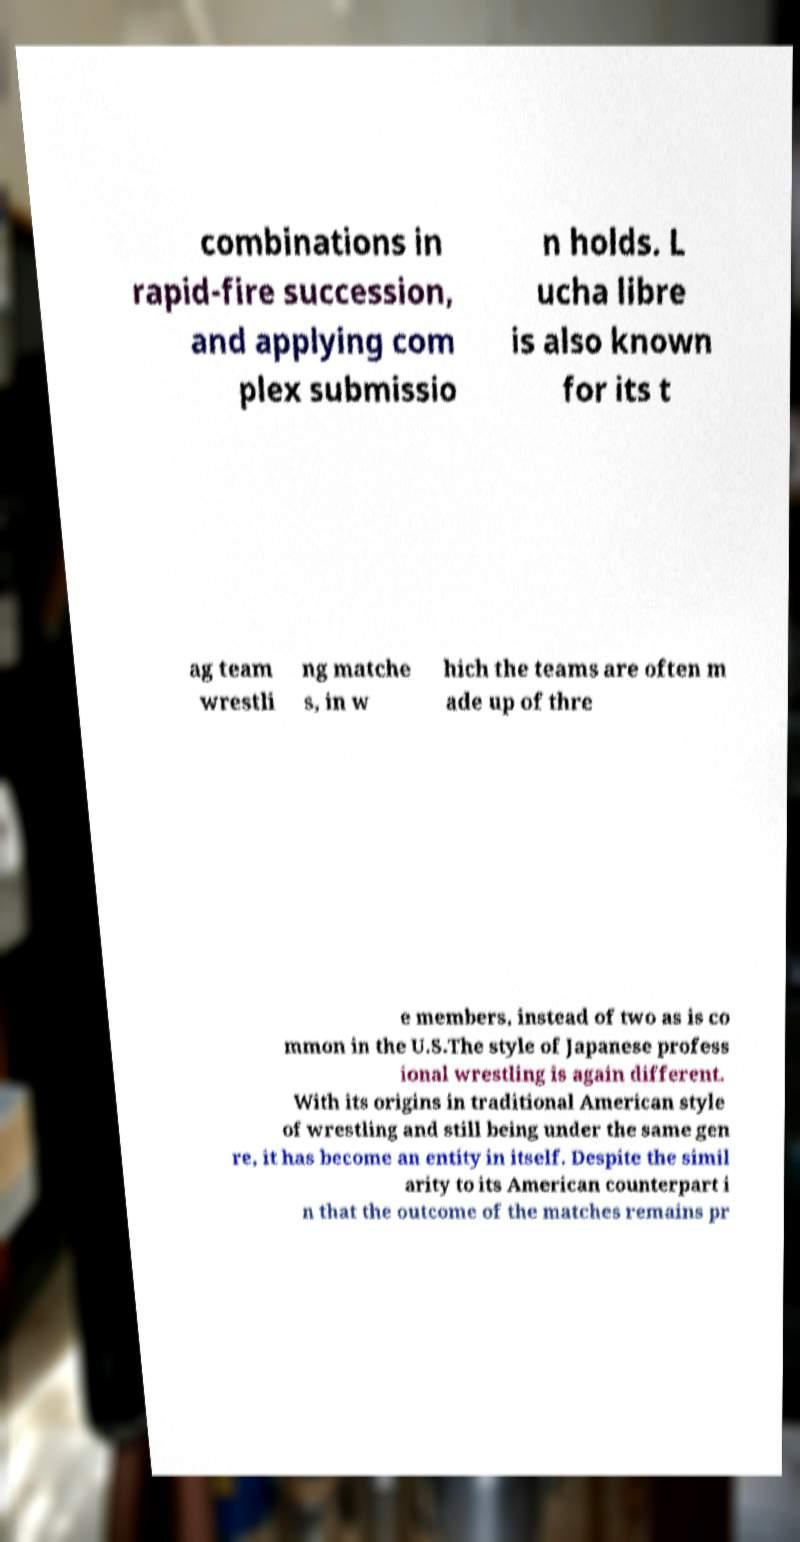There's text embedded in this image that I need extracted. Can you transcribe it verbatim? combinations in rapid-fire succession, and applying com plex submissio n holds. L ucha libre is also known for its t ag team wrestli ng matche s, in w hich the teams are often m ade up of thre e members, instead of two as is co mmon in the U.S.The style of Japanese profess ional wrestling is again different. With its origins in traditional American style of wrestling and still being under the same gen re, it has become an entity in itself. Despite the simil arity to its American counterpart i n that the outcome of the matches remains pr 